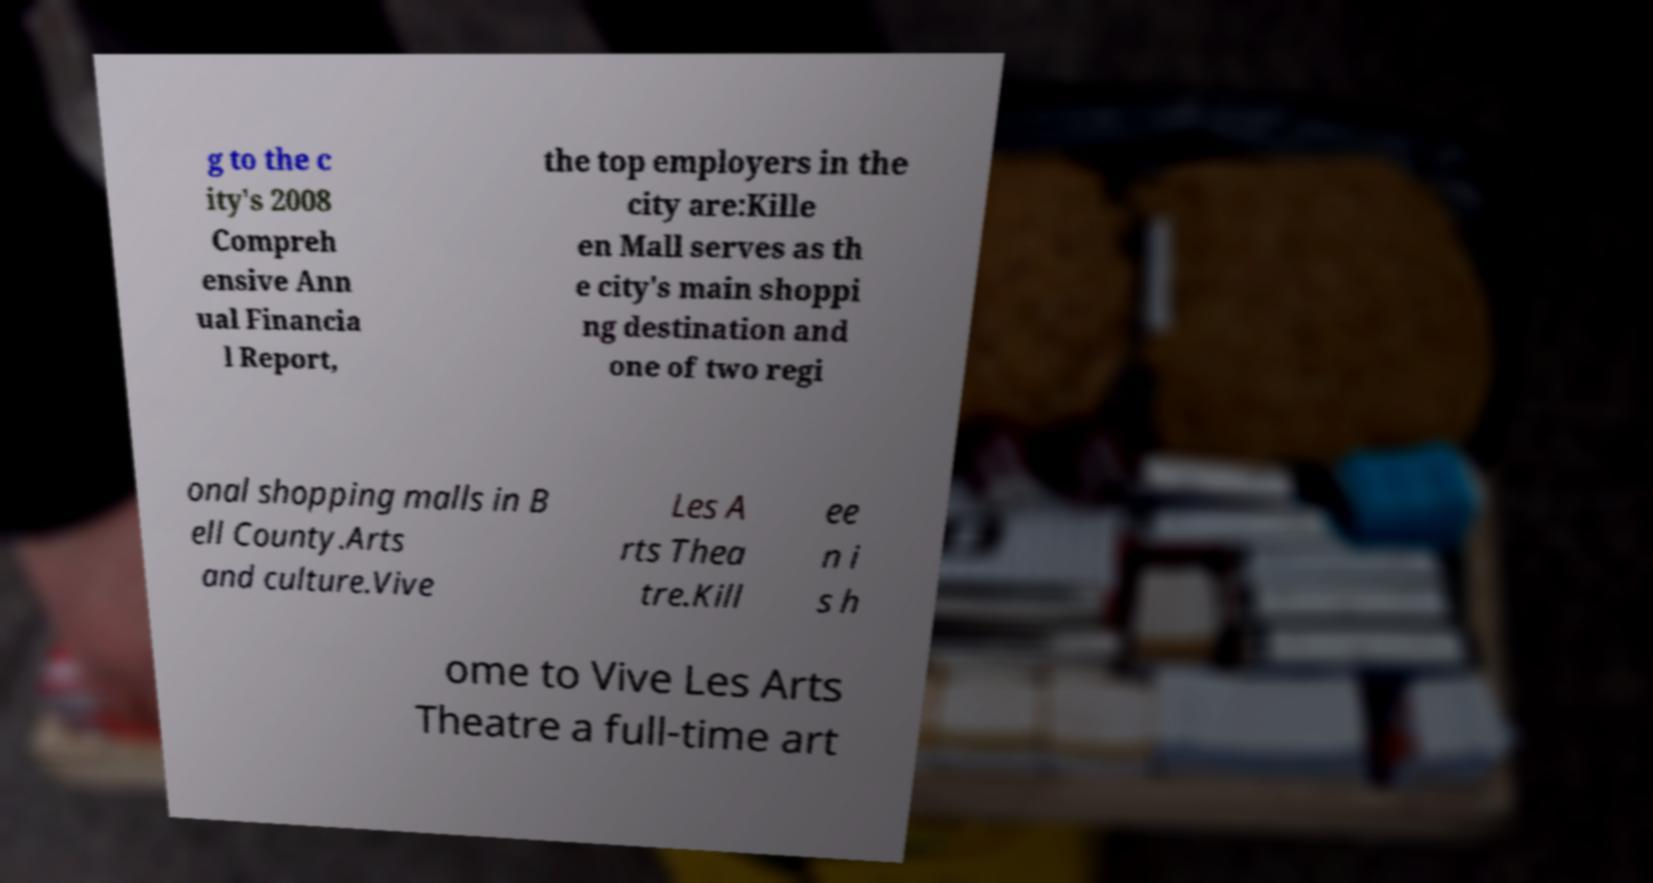Could you extract and type out the text from this image? g to the c ity's 2008 Compreh ensive Ann ual Financia l Report, the top employers in the city are:Kille en Mall serves as th e city's main shoppi ng destination and one of two regi onal shopping malls in B ell County.Arts and culture.Vive Les A rts Thea tre.Kill ee n i s h ome to Vive Les Arts Theatre a full-time art 